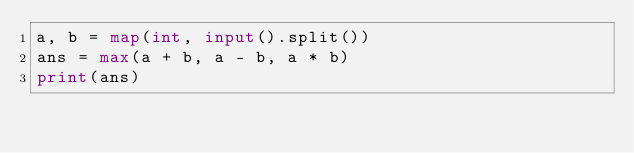Convert code to text. <code><loc_0><loc_0><loc_500><loc_500><_Python_>a, b = map(int, input().split())
ans = max(a + b, a - b, a * b)
print(ans)</code> 